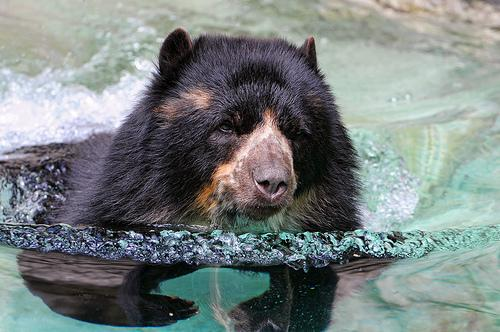Please provide a brief description of the bear's body parts that are depicted in the image. The bear has a head with two eyes, two ears, a nose, a mouth, and a snout, and at least two of its paws are submerged underwater. Is the water clear or murky in the image? How can you describe its quality? The water appears clear with some bright blue-green shades, and you can see ripples and small waves. Describe an interaction between the bear and its surroundings in the image. The bear is swimming in the water, causing ripples, splashes, and small waves around it, as it moves through the clear water. What are the emotions you can infer from the scene in the image? The scene appears calm and peaceful, as a bear is swimming in clear water, relaxed and content with its environment. How do the eyes of the bear in the image appear? The eyes of the bear appear calm and focused, and there are two eyes present on its face. In the image, mention one detail about the bear's fur color and condition. The fur of the bear is mostly wet and appears to be black in color. Identify and count the paws of the bear that are visible in the image. Two paws of the bear are visible, both appearing to be submerged under water. How many of the bear's nostrils are visible in the image? One nostril of the bear is visible in the image. What kind of animal is the main subject in the image and what is its activity? A bear, possibly a black or brown bear, is swimming in water surrounded by splashes and ripples. Could you describe the bear's general appearance and its environment in the image? The bear has a wet, black fur with a brown nose and is swimming in clear, blue-green water, facing the camera. 